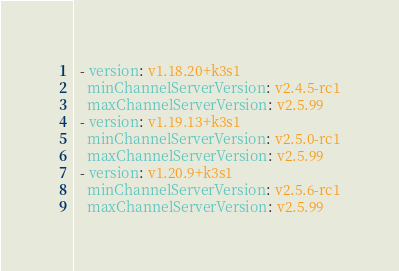Convert code to text. <code><loc_0><loc_0><loc_500><loc_500><_YAML_>  - version: v1.18.20+k3s1
    minChannelServerVersion: v2.4.5-rc1
    maxChannelServerVersion: v2.5.99
  - version: v1.19.13+k3s1
    minChannelServerVersion: v2.5.0-rc1
    maxChannelServerVersion: v2.5.99
  - version: v1.20.9+k3s1
    minChannelServerVersion: v2.5.6-rc1
    maxChannelServerVersion: v2.5.99
</code> 